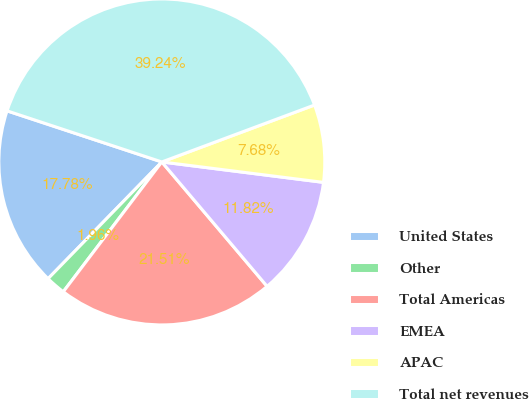<chart> <loc_0><loc_0><loc_500><loc_500><pie_chart><fcel>United States<fcel>Other<fcel>Total Americas<fcel>EMEA<fcel>APAC<fcel>Total net revenues<nl><fcel>17.78%<fcel>1.96%<fcel>21.51%<fcel>11.82%<fcel>7.68%<fcel>39.24%<nl></chart> 